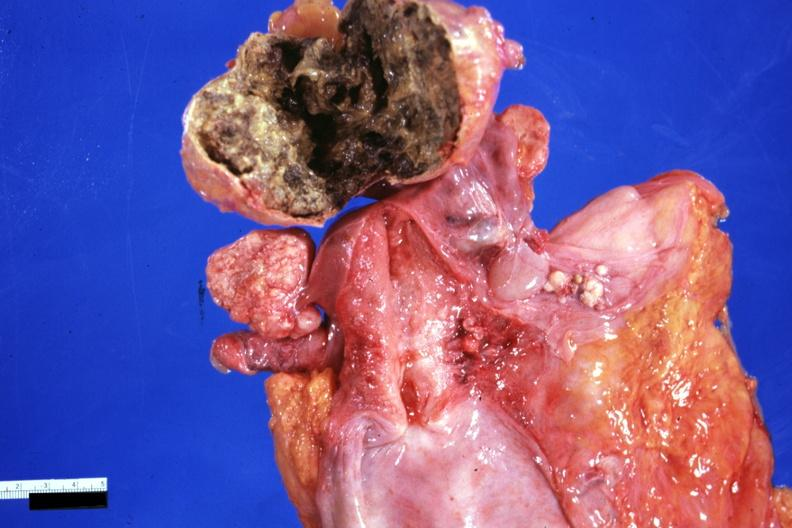what does this image show?
Answer the question using a single word or phrase. Necrotic central mass with thin fibrous capsule not all that typical 91yo 